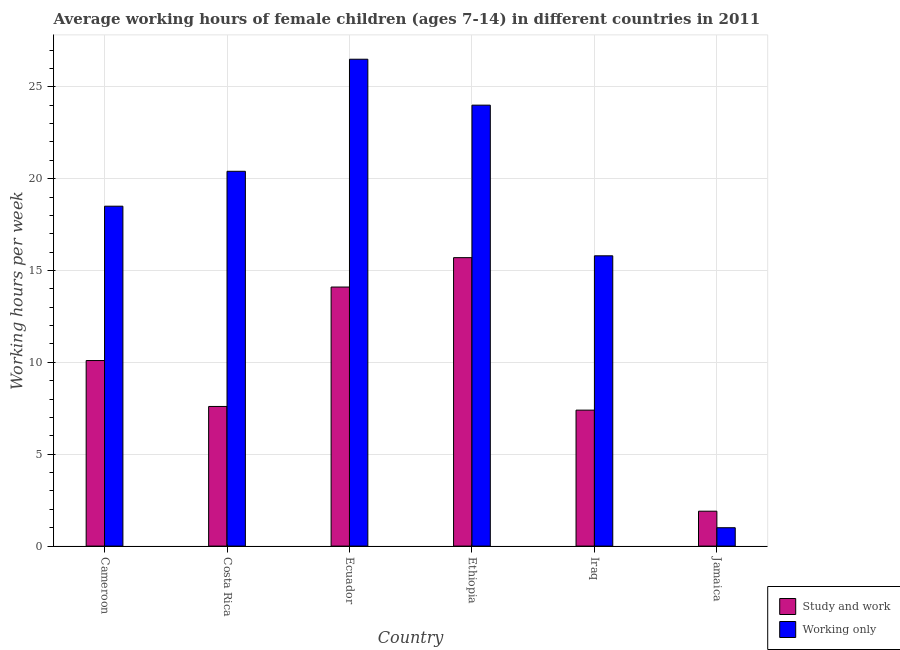How many different coloured bars are there?
Provide a succinct answer. 2. How many groups of bars are there?
Give a very brief answer. 6. What is the label of the 1st group of bars from the left?
Offer a very short reply. Cameroon. In which country was the average working hour of children involved in study and work maximum?
Your answer should be very brief. Ethiopia. In which country was the average working hour of children involved in study and work minimum?
Your response must be concise. Jamaica. What is the total average working hour of children involved in only work in the graph?
Your answer should be very brief. 106.2. What is the difference between the average working hour of children involved in study and work in Costa Rica and the average working hour of children involved in only work in Ethiopia?
Provide a succinct answer. -16.4. What is the average average working hour of children involved in study and work per country?
Offer a very short reply. 9.47. What is the difference between the average working hour of children involved in only work and average working hour of children involved in study and work in Iraq?
Offer a very short reply. 8.4. In how many countries, is the average working hour of children involved in only work greater than 22 hours?
Keep it short and to the point. 2. What is the ratio of the average working hour of children involved in study and work in Cameroon to that in Ecuador?
Make the answer very short. 0.72. In how many countries, is the average working hour of children involved in study and work greater than the average average working hour of children involved in study and work taken over all countries?
Provide a succinct answer. 3. Is the sum of the average working hour of children involved in only work in Costa Rica and Ethiopia greater than the maximum average working hour of children involved in study and work across all countries?
Your response must be concise. Yes. What does the 2nd bar from the left in Ethiopia represents?
Your answer should be very brief. Working only. What does the 2nd bar from the right in Jamaica represents?
Your answer should be very brief. Study and work. What is the difference between two consecutive major ticks on the Y-axis?
Your answer should be compact. 5. Are the values on the major ticks of Y-axis written in scientific E-notation?
Keep it short and to the point. No. Where does the legend appear in the graph?
Offer a very short reply. Bottom right. What is the title of the graph?
Keep it short and to the point. Average working hours of female children (ages 7-14) in different countries in 2011. Does "Primary" appear as one of the legend labels in the graph?
Provide a succinct answer. No. What is the label or title of the Y-axis?
Offer a very short reply. Working hours per week. What is the Working hours per week of Study and work in Cameroon?
Provide a succinct answer. 10.1. What is the Working hours per week in Working only in Cameroon?
Your answer should be compact. 18.5. What is the Working hours per week of Study and work in Costa Rica?
Your answer should be very brief. 7.6. What is the Working hours per week in Working only in Costa Rica?
Your answer should be compact. 20.4. What is the Working hours per week in Working only in Ecuador?
Offer a very short reply. 26.5. What is the Working hours per week in Working only in Ethiopia?
Ensure brevity in your answer.  24. What is the Working hours per week in Study and work in Iraq?
Your answer should be very brief. 7.4. What is the Working hours per week in Study and work in Jamaica?
Ensure brevity in your answer.  1.9. What is the Working hours per week in Working only in Jamaica?
Offer a very short reply. 1. Across all countries, what is the maximum Working hours per week of Study and work?
Keep it short and to the point. 15.7. Across all countries, what is the minimum Working hours per week in Study and work?
Provide a short and direct response. 1.9. What is the total Working hours per week in Study and work in the graph?
Provide a short and direct response. 56.8. What is the total Working hours per week in Working only in the graph?
Keep it short and to the point. 106.2. What is the difference between the Working hours per week of Study and work in Cameroon and that in Ecuador?
Your response must be concise. -4. What is the difference between the Working hours per week of Study and work in Cameroon and that in Ethiopia?
Keep it short and to the point. -5.6. What is the difference between the Working hours per week of Study and work in Cameroon and that in Iraq?
Give a very brief answer. 2.7. What is the difference between the Working hours per week of Working only in Cameroon and that in Iraq?
Offer a very short reply. 2.7. What is the difference between the Working hours per week in Working only in Costa Rica and that in Ecuador?
Your response must be concise. -6.1. What is the difference between the Working hours per week of Working only in Costa Rica and that in Ethiopia?
Your response must be concise. -3.6. What is the difference between the Working hours per week in Study and work in Costa Rica and that in Iraq?
Give a very brief answer. 0.2. What is the difference between the Working hours per week of Working only in Costa Rica and that in Jamaica?
Provide a succinct answer. 19.4. What is the difference between the Working hours per week of Study and work in Ecuador and that in Ethiopia?
Your answer should be very brief. -1.6. What is the difference between the Working hours per week in Working only in Ecuador and that in Iraq?
Your answer should be very brief. 10.7. What is the difference between the Working hours per week of Study and work in Ecuador and that in Jamaica?
Offer a very short reply. 12.2. What is the difference between the Working hours per week in Study and work in Ethiopia and that in Iraq?
Your answer should be very brief. 8.3. What is the difference between the Working hours per week in Study and work in Ethiopia and that in Jamaica?
Your response must be concise. 13.8. What is the difference between the Working hours per week in Study and work in Cameroon and the Working hours per week in Working only in Costa Rica?
Ensure brevity in your answer.  -10.3. What is the difference between the Working hours per week in Study and work in Cameroon and the Working hours per week in Working only in Ecuador?
Provide a short and direct response. -16.4. What is the difference between the Working hours per week of Study and work in Cameroon and the Working hours per week of Working only in Ethiopia?
Provide a succinct answer. -13.9. What is the difference between the Working hours per week in Study and work in Cameroon and the Working hours per week in Working only in Iraq?
Provide a succinct answer. -5.7. What is the difference between the Working hours per week in Study and work in Costa Rica and the Working hours per week in Working only in Ecuador?
Your answer should be very brief. -18.9. What is the difference between the Working hours per week in Study and work in Costa Rica and the Working hours per week in Working only in Ethiopia?
Ensure brevity in your answer.  -16.4. What is the difference between the Working hours per week in Study and work in Costa Rica and the Working hours per week in Working only in Iraq?
Your response must be concise. -8.2. What is the difference between the Working hours per week in Study and work in Ecuador and the Working hours per week in Working only in Ethiopia?
Make the answer very short. -9.9. What is the difference between the Working hours per week in Study and work in Ecuador and the Working hours per week in Working only in Jamaica?
Your answer should be very brief. 13.1. What is the difference between the Working hours per week of Study and work in Ethiopia and the Working hours per week of Working only in Iraq?
Make the answer very short. -0.1. What is the average Working hours per week of Study and work per country?
Offer a very short reply. 9.47. What is the average Working hours per week in Working only per country?
Keep it short and to the point. 17.7. What is the difference between the Working hours per week of Study and work and Working hours per week of Working only in Iraq?
Provide a short and direct response. -8.4. What is the difference between the Working hours per week in Study and work and Working hours per week in Working only in Jamaica?
Offer a terse response. 0.9. What is the ratio of the Working hours per week in Study and work in Cameroon to that in Costa Rica?
Your answer should be very brief. 1.33. What is the ratio of the Working hours per week in Working only in Cameroon to that in Costa Rica?
Make the answer very short. 0.91. What is the ratio of the Working hours per week of Study and work in Cameroon to that in Ecuador?
Provide a short and direct response. 0.72. What is the ratio of the Working hours per week of Working only in Cameroon to that in Ecuador?
Your answer should be very brief. 0.7. What is the ratio of the Working hours per week of Study and work in Cameroon to that in Ethiopia?
Provide a short and direct response. 0.64. What is the ratio of the Working hours per week in Working only in Cameroon to that in Ethiopia?
Your response must be concise. 0.77. What is the ratio of the Working hours per week of Study and work in Cameroon to that in Iraq?
Your answer should be very brief. 1.36. What is the ratio of the Working hours per week in Working only in Cameroon to that in Iraq?
Offer a very short reply. 1.17. What is the ratio of the Working hours per week in Study and work in Cameroon to that in Jamaica?
Your answer should be compact. 5.32. What is the ratio of the Working hours per week of Working only in Cameroon to that in Jamaica?
Provide a short and direct response. 18.5. What is the ratio of the Working hours per week of Study and work in Costa Rica to that in Ecuador?
Provide a short and direct response. 0.54. What is the ratio of the Working hours per week in Working only in Costa Rica to that in Ecuador?
Offer a very short reply. 0.77. What is the ratio of the Working hours per week in Study and work in Costa Rica to that in Ethiopia?
Ensure brevity in your answer.  0.48. What is the ratio of the Working hours per week in Study and work in Costa Rica to that in Iraq?
Make the answer very short. 1.03. What is the ratio of the Working hours per week of Working only in Costa Rica to that in Iraq?
Your response must be concise. 1.29. What is the ratio of the Working hours per week of Working only in Costa Rica to that in Jamaica?
Your answer should be very brief. 20.4. What is the ratio of the Working hours per week in Study and work in Ecuador to that in Ethiopia?
Ensure brevity in your answer.  0.9. What is the ratio of the Working hours per week in Working only in Ecuador to that in Ethiopia?
Offer a very short reply. 1.1. What is the ratio of the Working hours per week in Study and work in Ecuador to that in Iraq?
Make the answer very short. 1.91. What is the ratio of the Working hours per week in Working only in Ecuador to that in Iraq?
Provide a short and direct response. 1.68. What is the ratio of the Working hours per week of Study and work in Ecuador to that in Jamaica?
Keep it short and to the point. 7.42. What is the ratio of the Working hours per week in Working only in Ecuador to that in Jamaica?
Offer a terse response. 26.5. What is the ratio of the Working hours per week of Study and work in Ethiopia to that in Iraq?
Give a very brief answer. 2.12. What is the ratio of the Working hours per week of Working only in Ethiopia to that in Iraq?
Provide a short and direct response. 1.52. What is the ratio of the Working hours per week of Study and work in Ethiopia to that in Jamaica?
Provide a short and direct response. 8.26. What is the ratio of the Working hours per week of Study and work in Iraq to that in Jamaica?
Your response must be concise. 3.89. What is the ratio of the Working hours per week of Working only in Iraq to that in Jamaica?
Make the answer very short. 15.8. What is the difference between the highest and the second highest Working hours per week in Study and work?
Your answer should be very brief. 1.6. What is the difference between the highest and the lowest Working hours per week in Study and work?
Give a very brief answer. 13.8. 